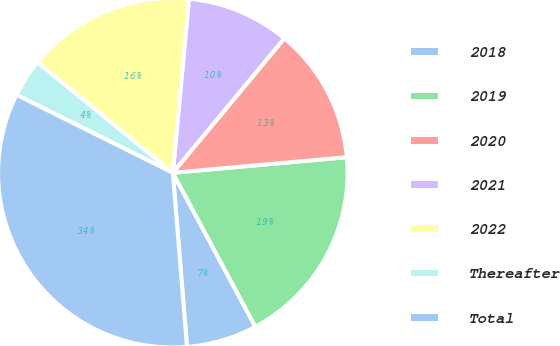Convert chart to OTSL. <chart><loc_0><loc_0><loc_500><loc_500><pie_chart><fcel>2018<fcel>2019<fcel>2020<fcel>2021<fcel>2022<fcel>Thereafter<fcel>Total<nl><fcel>6.54%<fcel>18.59%<fcel>12.56%<fcel>9.55%<fcel>15.58%<fcel>3.53%<fcel>33.65%<nl></chart> 